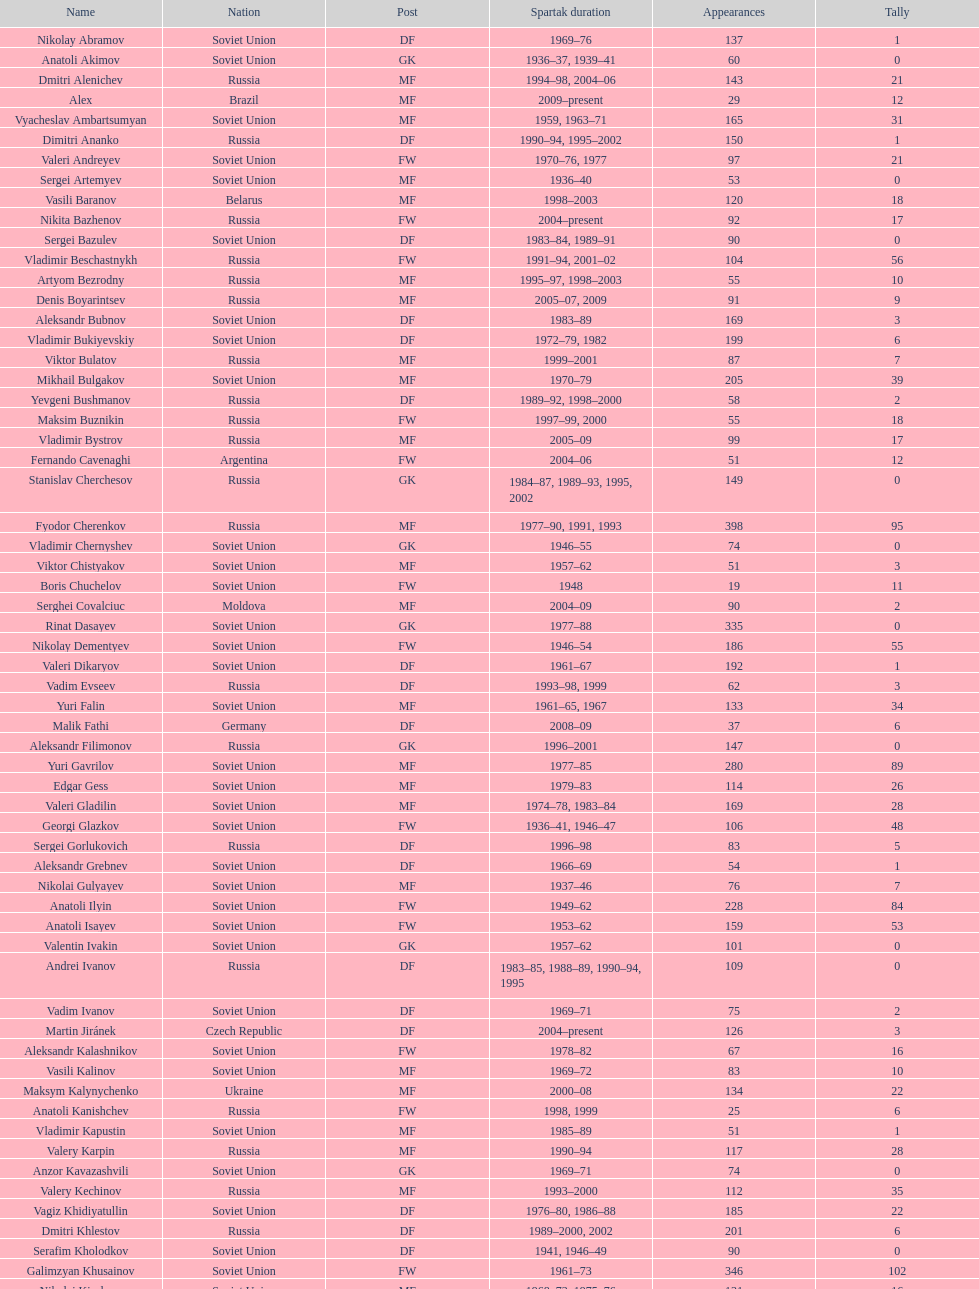Name two players with goals above 15. Dmitri Alenichev, Vyacheslav Ambartsumyan. Can you parse all the data within this table? {'header': ['Name', 'Nation', 'Post', 'Spartak duration', 'Appearances', 'Tally'], 'rows': [['Nikolay Abramov', 'Soviet Union', 'DF', '1969–76', '137', '1'], ['Anatoli Akimov', 'Soviet Union', 'GK', '1936–37, 1939–41', '60', '0'], ['Dmitri Alenichev', 'Russia', 'MF', '1994–98, 2004–06', '143', '21'], ['Alex', 'Brazil', 'MF', '2009–present', '29', '12'], ['Vyacheslav Ambartsumyan', 'Soviet Union', 'MF', '1959, 1963–71', '165', '31'], ['Dimitri Ananko', 'Russia', 'DF', '1990–94, 1995–2002', '150', '1'], ['Valeri Andreyev', 'Soviet Union', 'FW', '1970–76, 1977', '97', '21'], ['Sergei Artemyev', 'Soviet Union', 'MF', '1936–40', '53', '0'], ['Vasili Baranov', 'Belarus', 'MF', '1998–2003', '120', '18'], ['Nikita Bazhenov', 'Russia', 'FW', '2004–present', '92', '17'], ['Sergei Bazulev', 'Soviet Union', 'DF', '1983–84, 1989–91', '90', '0'], ['Vladimir Beschastnykh', 'Russia', 'FW', '1991–94, 2001–02', '104', '56'], ['Artyom Bezrodny', 'Russia', 'MF', '1995–97, 1998–2003', '55', '10'], ['Denis Boyarintsev', 'Russia', 'MF', '2005–07, 2009', '91', '9'], ['Aleksandr Bubnov', 'Soviet Union', 'DF', '1983–89', '169', '3'], ['Vladimir Bukiyevskiy', 'Soviet Union', 'DF', '1972–79, 1982', '199', '6'], ['Viktor Bulatov', 'Russia', 'MF', '1999–2001', '87', '7'], ['Mikhail Bulgakov', 'Soviet Union', 'MF', '1970–79', '205', '39'], ['Yevgeni Bushmanov', 'Russia', 'DF', '1989–92, 1998–2000', '58', '2'], ['Maksim Buznikin', 'Russia', 'FW', '1997–99, 2000', '55', '18'], ['Vladimir Bystrov', 'Russia', 'MF', '2005–09', '99', '17'], ['Fernando Cavenaghi', 'Argentina', 'FW', '2004–06', '51', '12'], ['Stanislav Cherchesov', 'Russia', 'GK', '1984–87, 1989–93, 1995, 2002', '149', '0'], ['Fyodor Cherenkov', 'Russia', 'MF', '1977–90, 1991, 1993', '398', '95'], ['Vladimir Chernyshev', 'Soviet Union', 'GK', '1946–55', '74', '0'], ['Viktor Chistyakov', 'Soviet Union', 'MF', '1957–62', '51', '3'], ['Boris Chuchelov', 'Soviet Union', 'FW', '1948', '19', '11'], ['Serghei Covalciuc', 'Moldova', 'MF', '2004–09', '90', '2'], ['Rinat Dasayev', 'Soviet Union', 'GK', '1977–88', '335', '0'], ['Nikolay Dementyev', 'Soviet Union', 'FW', '1946–54', '186', '55'], ['Valeri Dikaryov', 'Soviet Union', 'DF', '1961–67', '192', '1'], ['Vadim Evseev', 'Russia', 'DF', '1993–98, 1999', '62', '3'], ['Yuri Falin', 'Soviet Union', 'MF', '1961–65, 1967', '133', '34'], ['Malik Fathi', 'Germany', 'DF', '2008–09', '37', '6'], ['Aleksandr Filimonov', 'Russia', 'GK', '1996–2001', '147', '0'], ['Yuri Gavrilov', 'Soviet Union', 'MF', '1977–85', '280', '89'], ['Edgar Gess', 'Soviet Union', 'MF', '1979–83', '114', '26'], ['Valeri Gladilin', 'Soviet Union', 'MF', '1974–78, 1983–84', '169', '28'], ['Georgi Glazkov', 'Soviet Union', 'FW', '1936–41, 1946–47', '106', '48'], ['Sergei Gorlukovich', 'Russia', 'DF', '1996–98', '83', '5'], ['Aleksandr Grebnev', 'Soviet Union', 'DF', '1966–69', '54', '1'], ['Nikolai Gulyayev', 'Soviet Union', 'MF', '1937–46', '76', '7'], ['Anatoli Ilyin', 'Soviet Union', 'FW', '1949–62', '228', '84'], ['Anatoli Isayev', 'Soviet Union', 'FW', '1953–62', '159', '53'], ['Valentin Ivakin', 'Soviet Union', 'GK', '1957–62', '101', '0'], ['Andrei Ivanov', 'Russia', 'DF', '1983–85, 1988–89, 1990–94, 1995', '109', '0'], ['Vadim Ivanov', 'Soviet Union', 'DF', '1969–71', '75', '2'], ['Martin Jiránek', 'Czech Republic', 'DF', '2004–present', '126', '3'], ['Aleksandr Kalashnikov', 'Soviet Union', 'FW', '1978–82', '67', '16'], ['Vasili Kalinov', 'Soviet Union', 'MF', '1969–72', '83', '10'], ['Maksym Kalynychenko', 'Ukraine', 'MF', '2000–08', '134', '22'], ['Anatoli Kanishchev', 'Russia', 'FW', '1998, 1999', '25', '6'], ['Vladimir Kapustin', 'Soviet Union', 'MF', '1985–89', '51', '1'], ['Valery Karpin', 'Russia', 'MF', '1990–94', '117', '28'], ['Anzor Kavazashvili', 'Soviet Union', 'GK', '1969–71', '74', '0'], ['Valery Kechinov', 'Russia', 'MF', '1993–2000', '112', '35'], ['Vagiz Khidiyatullin', 'Soviet Union', 'DF', '1976–80, 1986–88', '185', '22'], ['Dmitri Khlestov', 'Russia', 'DF', '1989–2000, 2002', '201', '6'], ['Serafim Kholodkov', 'Soviet Union', 'DF', '1941, 1946–49', '90', '0'], ['Galimzyan Khusainov', 'Soviet Union', 'FW', '1961–73', '346', '102'], ['Nikolai Kiselyov', 'Soviet Union', 'MF', '1968–73, 1975–76', '131', '16'], ['Aleksandr Kokorev', 'Soviet Union', 'MF', '1972–80', '90', '4'], ['Ivan Konov', 'Soviet Union', 'FW', '1945–48', '85', '31'], ['Viktor Konovalov', 'Soviet Union', 'MF', '1960–61', '24', '5'], ['Alexey Korneyev', 'Soviet Union', 'DF', '1957–67', '177', '0'], ['Pavel Kornilov', 'Soviet Union', 'FW', '1938–41', '65', '38'], ['Radoslav Kováč', 'Czech Republic', 'MF', '2005–08', '101', '9'], ['Yuri Kovtun', 'Russia', 'DF', '1999–2005', '122', '7'], ['Wojciech Kowalewski', 'Poland', 'GK', '2003–07', '94', '0'], ['Anatoly Krutikov', 'Soviet Union', 'DF', '1959–69', '269', '9'], ['Dmitri Kudryashov', 'Russia', 'MF', '2002', '22', '5'], ['Vasili Kulkov', 'Russia', 'DF', '1986, 1989–91, 1995, 1997', '93', '4'], ['Boris Kuznetsov', 'Soviet Union', 'DF', '1985–88, 1989–90', '90', '0'], ['Yevgeni Kuznetsov', 'Soviet Union', 'MF', '1982–89', '209', '23'], ['Igor Lediakhov', 'Russia', 'MF', '1992–94', '65', '21'], ['Aleksei Leontyev', 'Soviet Union', 'GK', '1940–49', '109', '0'], ['Boris Lobutev', 'Soviet Union', 'FW', '1957–60', '15', '7'], ['Gennady Logofet', 'Soviet Union', 'DF', '1960–75', '349', '27'], ['Evgeny Lovchev', 'Soviet Union', 'MF', '1969–78', '249', '30'], ['Konstantin Malinin', 'Soviet Union', 'DF', '1939–50', '140', '7'], ['Ramiz Mamedov', 'Russia', 'DF', '1991–98', '125', '6'], ['Valeri Masalitin', 'Russia', 'FW', '1994–95', '7', '5'], ['Vladimir Maslachenko', 'Soviet Union', 'GK', '1962–68', '196', '0'], ['Anatoli Maslyonkin', 'Soviet Union', 'DF', '1954–63', '216', '8'], ['Aleksei Melyoshin', 'Russia', 'MF', '1995–2000', '68', '5'], ['Aleksandr Minayev', 'Soviet Union', 'MF', '1972–75', '92', '10'], ['Alexander Mirzoyan', 'Soviet Union', 'DF', '1979–83', '80', '9'], ['Vitali Mirzoyev', 'Soviet Union', 'FW', '1971–74', '58', '4'], ['Viktor Mishin', 'Soviet Union', 'FW', '1956–61', '43', '8'], ['Igor Mitreski', 'Macedonia', 'DF', '2001–04', '85', '0'], ['Gennady Morozov', 'Soviet Union', 'DF', '1980–86, 1989–90', '196', '3'], ['Aleksandr Mostovoi', 'Soviet Union', 'MF', '1986–91', '106', '34'], ['Mozart', 'Brazil', 'MF', '2005–08', '68', '7'], ['Ivan Mozer', 'Soviet Union', 'MF', '1956–61', '96', '30'], ['Mukhsin Mukhamadiev', 'Russia', 'MF', '1994–95', '30', '13'], ['Igor Netto', 'Soviet Union', 'MF', '1949–66', '368', '36'], ['Yuriy Nikiforov', 'Russia', 'DF', '1993–96', '85', '16'], ['Vladimir Nikonov', 'Soviet Union', 'MF', '1979–80, 1982', '25', '5'], ['Sergei Novikov', 'Soviet Union', 'MF', '1978–80, 1985–89', '70', '12'], ['Mikhail Ogonkov', 'Soviet Union', 'DF', '1953–58, 1961', '78', '0'], ['Sergei Olshansky', 'Soviet Union', 'DF', '1969–75', '138', '7'], ['Viktor Onopko', 'Russia', 'DF', '1992–95', '108', '23'], ['Nikolai Osyanin', 'Soviet Union', 'DF', '1966–71, 1974–76', '248', '50'], ['Viktor Papayev', 'Soviet Union', 'MF', '1968–73, 1975–76', '174', '10'], ['Aleksei Paramonov', 'Soviet Union', 'MF', '1947–59', '264', '61'], ['Dmytro Parfenov', 'Ukraine', 'DF', '1998–2005', '125', '15'], ['Nikolai Parshin', 'Soviet Union', 'FW', '1949–58', '106', '36'], ['Viktor Pasulko', 'Soviet Union', 'MF', '1987–89', '75', '16'], ['Aleksandr Pavlenko', 'Russia', 'MF', '2001–07, 2008–09', '110', '11'], ['Vadim Pavlenko', 'Soviet Union', 'FW', '1977–78', '47', '16'], ['Roman Pavlyuchenko', 'Russia', 'FW', '2003–08', '141', '69'], ['Hennadiy Perepadenko', 'Ukraine', 'MF', '1990–91, 1992', '51', '6'], ['Boris Petrov', 'Soviet Union', 'FW', '1962', '18', '5'], ['Vladimir Petrov', 'Soviet Union', 'DF', '1959–71', '174', '5'], ['Andrei Piatnitski', 'Russia', 'MF', '1992–97', '100', '17'], ['Nikolai Pisarev', 'Russia', 'FW', '1992–95, 1998, 2000–01', '115', '32'], ['Aleksandr Piskaryov', 'Soviet Union', 'FW', '1971–75', '117', '33'], ['Mihajlo Pjanović', 'Serbia', 'FW', '2003–06', '48', '11'], ['Stipe Pletikosa', 'Croatia', 'GK', '2007–present', '63', '0'], ['Dmitri Popov', 'Russia', 'DF', '1989–93', '78', '7'], ['Boris Pozdnyakov', 'Soviet Union', 'DF', '1978–84, 1989–91', '145', '3'], ['Vladimir Pribylov', 'Soviet Union', 'FW', '1964–69', '35', '6'], ['Aleksandr Prokhorov', 'Soviet Union', 'GK', '1972–75, 1976–78', '143', '0'], ['Andrei Protasov', 'Soviet Union', 'FW', '1939–41', '32', '10'], ['Dmitri Radchenko', 'Russia', 'FW', '1991–93', '61', '27'], ['Vladimir Redin', 'Soviet Union', 'MF', '1970–74, 1976', '90', '12'], ['Valeri Reyngold', 'Soviet Union', 'FW', '1960–67', '176', '32'], ['Luis Robson', 'Brazil', 'FW', '1997–2001', '102', '32'], ['Sergey Rodionov', 'Russia', 'FW', '1979–90, 1993–95', '303', '124'], ['Clemente Rodríguez', 'Argentina', 'DF', '2004–06, 2008–09', '71', '3'], ['Oleg Romantsev', 'Soviet Union', 'DF', '1976–83', '180', '6'], ['Miroslav Romaschenko', 'Belarus', 'MF', '1997–98', '42', '7'], ['Sergei Rozhkov', 'Soviet Union', 'MF', '1961–65, 1967–69, 1974', '143', '8'], ['Andrei Rudakov', 'Soviet Union', 'FW', '1985–87', '49', '17'], ['Leonid Rumyantsev', 'Soviet Union', 'FW', '1936–40', '26', '8'], ['Mikhail Rusyayev', 'Russia', 'FW', '1981–87, 1992', '47', '9'], ['Konstantin Ryazantsev', 'Soviet Union', 'MF', '1941, 1944–51', '114', '5'], ['Aleksandr Rystsov', 'Soviet Union', 'FW', '1947–54', '100', '16'], ['Sergei Salnikov', 'Soviet Union', 'FW', '1946–49, 1955–60', '201', '64'], ['Aleksandr Samedov', 'Russia', 'MF', '2001–05', '47', '6'], ['Viktor Samokhin', 'Soviet Union', 'MF', '1974–81', '188', '3'], ['Yuri Sedov', 'Soviet Union', 'DF', '1948–55, 1957–59', '176', '2'], ['Anatoli Seglin', 'Soviet Union', 'DF', '1945–52', '83', '0'], ['Viktor Semyonov', 'Soviet Union', 'FW', '1937–47', '104', '49'], ['Yuri Sevidov', 'Soviet Union', 'FW', '1960–65', '146', '54'], ['Igor Shalimov', 'Russia', 'MF', '1986–91', '95', '20'], ['Sergey Shavlo', 'Soviet Union', 'MF', '1977–82, 1984–85', '256', '48'], ['Aleksandr Shirko', 'Russia', 'FW', '1993–2001', '128', '40'], ['Roman Shishkin', 'Russia', 'DF', '2003–08', '54', '1'], ['Valeri Shmarov', 'Russia', 'FW', '1987–91, 1995–96', '143', '54'], ['Sergei Shvetsov', 'Soviet Union', 'DF', '1981–84', '68', '14'], ['Yevgeni Sidorov', 'Soviet Union', 'MF', '1974–81, 1984–85', '191', '18'], ['Dzhemal Silagadze', 'Soviet Union', 'FW', '1968–71, 1973', '91', '12'], ['Nikita Simonyan', 'Soviet Union', 'FW', '1949–59', '215', '135'], ['Boris Smyslov', 'Soviet Union', 'FW', '1945–48', '45', '6'], ['Florin Şoavă', 'Romania', 'DF', '2004–05, 2007–08', '52', '1'], ['Vladimir Sochnov', 'Soviet Union', 'DF', '1981–85, 1989', '148', '9'], ['Aleksei Sokolov', 'Soviet Union', 'FW', '1938–41, 1942, 1944–47', '114', '49'], ['Vasili Sokolov', 'Soviet Union', 'DF', '1938–41, 1942–51', '262', '2'], ['Viktor Sokolov', 'Soviet Union', 'DF', '1936–41, 1942–46', '121', '0'], ['Anatoli Soldatov', 'Soviet Union', 'DF', '1958–65', '113', '1'], ['Aleksandr Sorokin', 'Soviet Union', 'MF', '1977–80', '107', '9'], ['Andrei Starostin', 'Soviet Union', 'MF', '1936–40', '95', '4'], ['Vladimir Stepanov', 'Soviet Union', 'FW', '1936–41, 1942', '101', '33'], ['Andrejs Štolcers', 'Latvia', 'MF', '2000', '11', '5'], ['Martin Stranzl', 'Austria', 'DF', '2006–present', '80', '3'], ['Yuri Susloparov', 'Soviet Union', 'DF', '1986–90', '80', '1'], ['Yuri Syomin', 'Soviet Union', 'MF', '1965–67', '43', '6'], ['Dmitri Sychev', 'Russia', 'FW', '2002', '18', '9'], ['Boris Tatushin', 'Soviet Union', 'FW', '1953–58, 1961', '116', '38'], ['Viktor Terentyev', 'Soviet Union', 'FW', '1948–53', '103', '34'], ['Andrey Tikhonov', 'Russia', 'MF', '1992–2000', '191', '68'], ['Oleg Timakov', 'Soviet Union', 'MF', '1945–54', '182', '19'], ['Nikolai Tishchenko', 'Soviet Union', 'DF', '1951–58', '106', '0'], ['Yegor Titov', 'Russia', 'MF', '1992–2008', '324', '86'], ['Eduard Tsykhmeystruk', 'Ukraine', 'FW', '2001–02', '35', '5'], ['Ilya Tsymbalar', 'Russia', 'MF', '1993–99', '146', '42'], ['Grigori Tuchkov', 'Soviet Union', 'DF', '1937–41, 1942, 1944', '74', '2'], ['Vladas Tučkus', 'Soviet Union', 'GK', '1954–57', '60', '0'], ['Ivan Varlamov', 'Soviet Union', 'DF', '1964–68', '75', '0'], ['Welliton', 'Brazil', 'FW', '2007–present', '77', '51'], ['Vladimir Yanishevskiy', 'Soviet Union', 'FW', '1965–66', '46', '7'], ['Vladimir Yankin', 'Soviet Union', 'MF', '1966–70', '93', '19'], ['Georgi Yartsev', 'Soviet Union', 'FW', '1977–80', '116', '55'], ['Valentin Yemyshev', 'Soviet Union', 'FW', '1948–53', '23', '9'], ['Aleksei Yeryomenko', 'Soviet Union', 'MF', '1986–87', '26', '5'], ['Viktor Yevlentyev', 'Soviet Union', 'MF', '1963–65, 1967–70', '56', '11'], ['Sergei Yuran', 'Russia', 'FW', '1995, 1999', '26', '5'], ['Valeri Zenkov', 'Soviet Union', 'DF', '1971–74', '59', '1']]} 